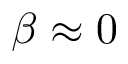<formula> <loc_0><loc_0><loc_500><loc_500>\beta \approx 0</formula> 